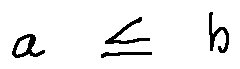Convert formula to latex. <formula><loc_0><loc_0><loc_500><loc_500>a \leq b</formula> 